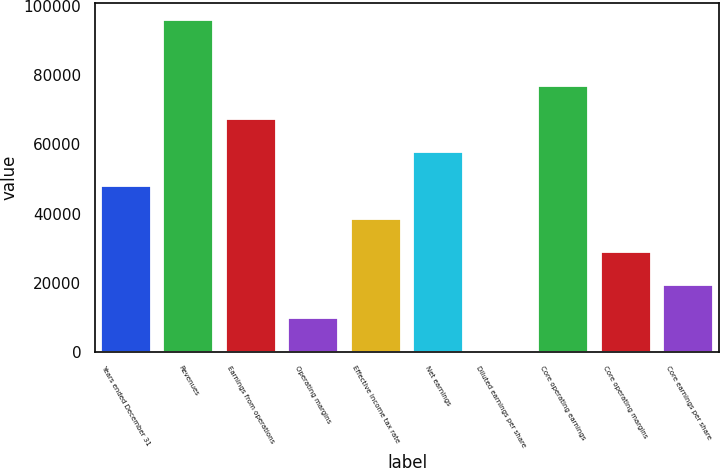Convert chart to OTSL. <chart><loc_0><loc_0><loc_500><loc_500><bar_chart><fcel>Years ended December 31<fcel>Revenues<fcel>Earnings from operations<fcel>Operating margins<fcel>Effective income tax rate<fcel>Net earnings<fcel>Diluted earnings per share<fcel>Core operating earnings<fcel>Core operating margins<fcel>Core earnings per share<nl><fcel>48060.7<fcel>96114<fcel>67282.1<fcel>9618.1<fcel>38450.1<fcel>57671.4<fcel>7.44<fcel>76892.7<fcel>28839.4<fcel>19228.8<nl></chart> 